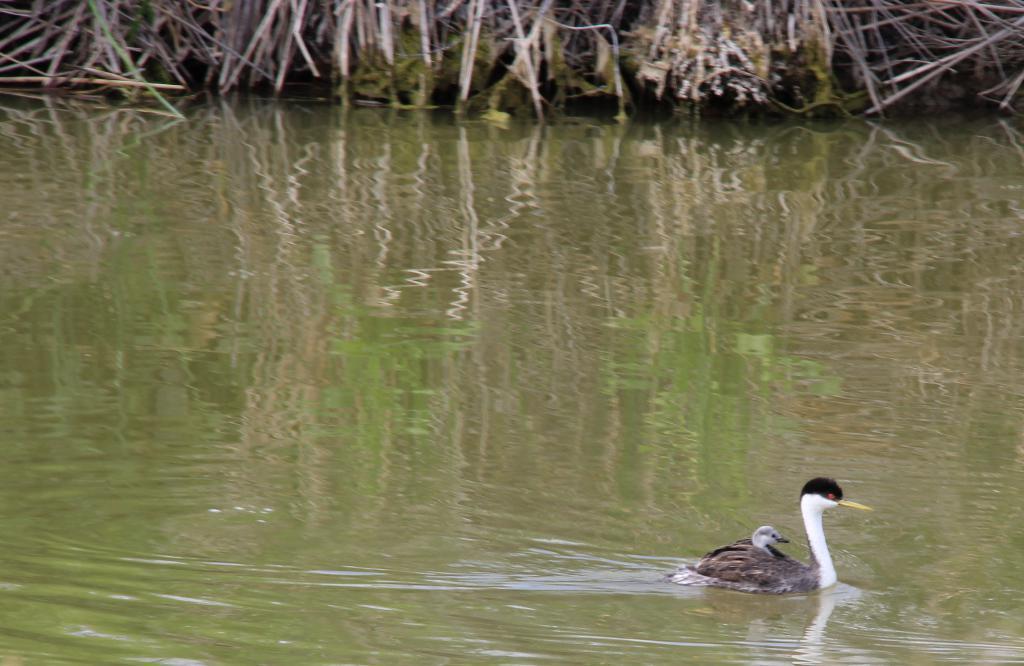Could you give a brief overview of what you see in this image? In this image I can see few birds in the water. Back I can see few dry grass. 